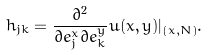<formula> <loc_0><loc_0><loc_500><loc_500>h _ { j k } = \frac { \partial ^ { 2 } } { \partial e _ { j } ^ { x } \partial e _ { k } ^ { y } } u ( x , y ) | _ { ( x , N ) } .</formula> 